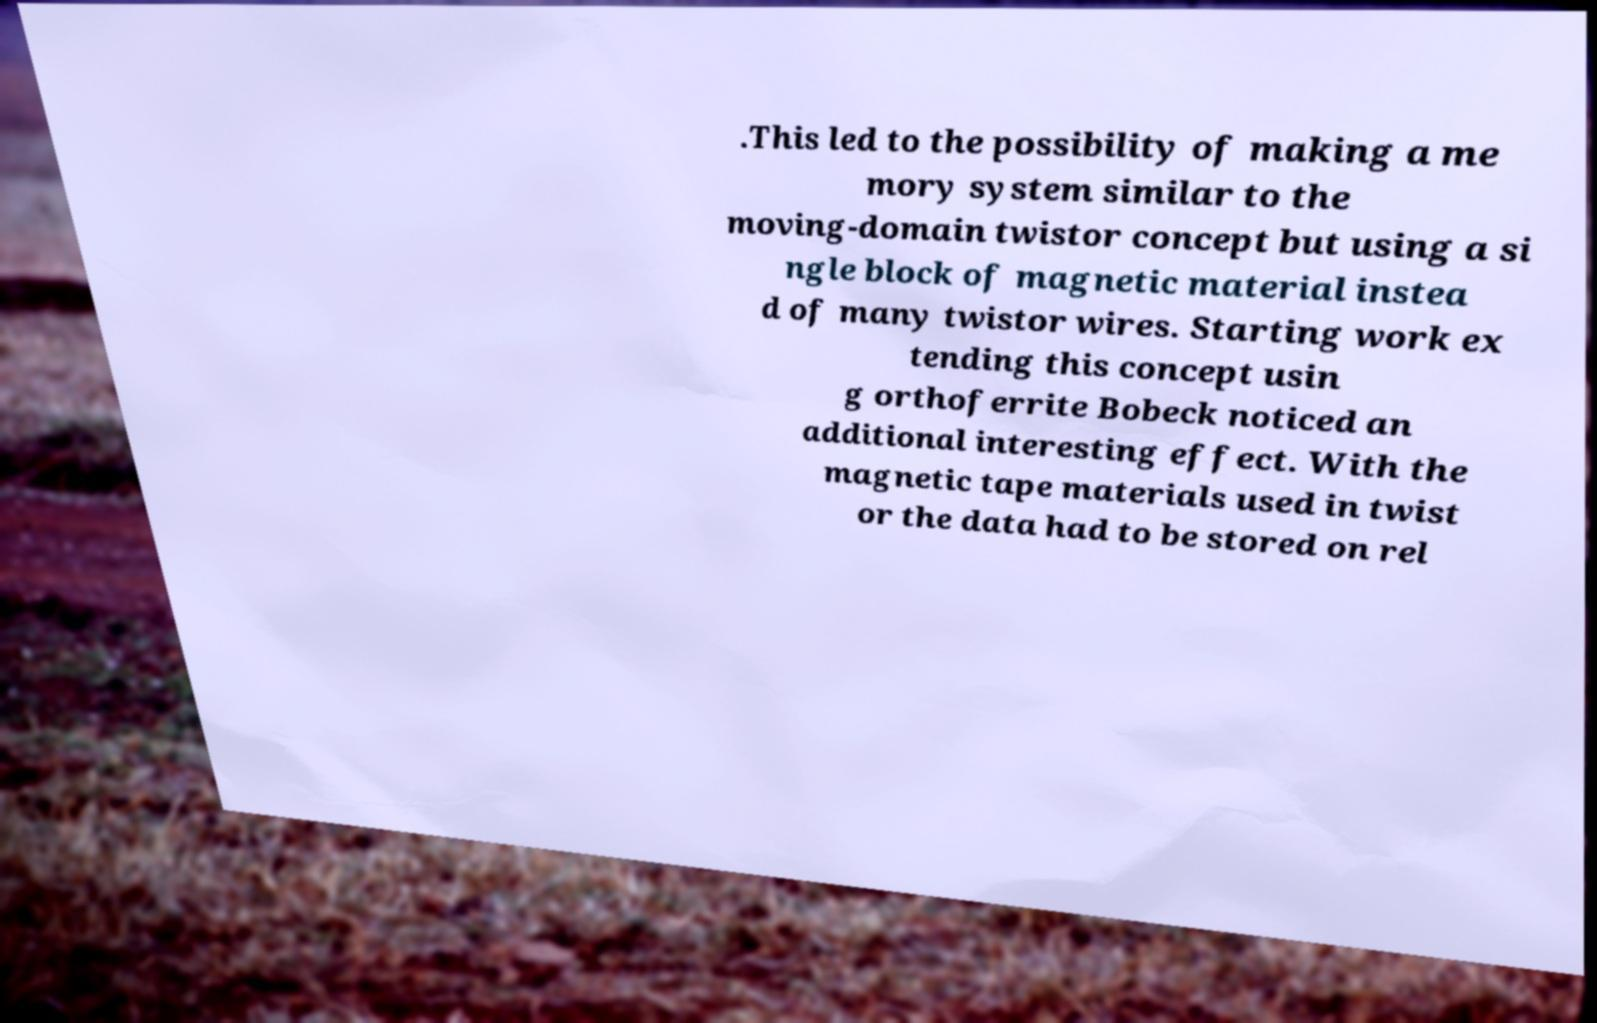Can you accurately transcribe the text from the provided image for me? .This led to the possibility of making a me mory system similar to the moving-domain twistor concept but using a si ngle block of magnetic material instea d of many twistor wires. Starting work ex tending this concept usin g orthoferrite Bobeck noticed an additional interesting effect. With the magnetic tape materials used in twist or the data had to be stored on rel 